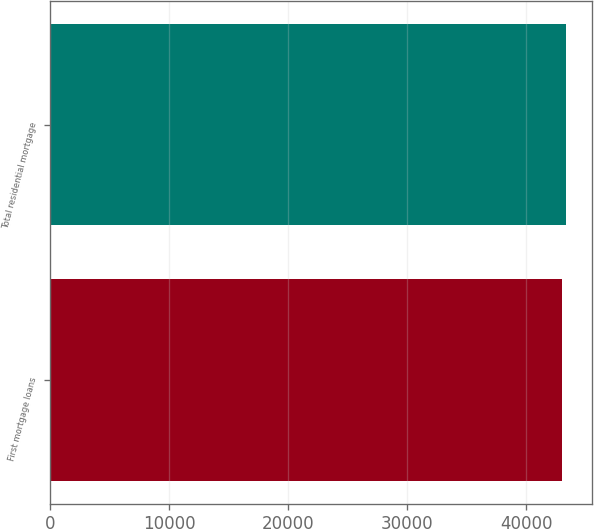Convert chart to OTSL. <chart><loc_0><loc_0><loc_500><loc_500><bar_chart><fcel>First mortgage loans<fcel>Total residential mortgage<nl><fcel>43004<fcel>43376<nl></chart> 